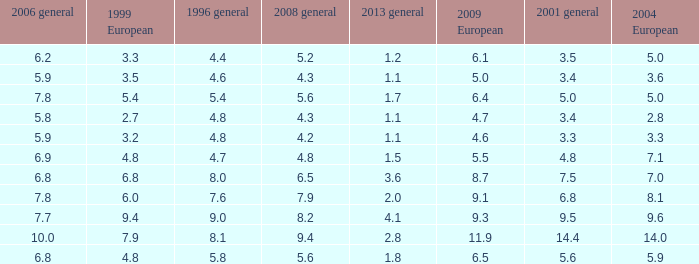What is the average value for general 2001 with more than 4.8 in 1999 European, 7.7 in 2006 general, and more than 9 in 1996 general? None. 